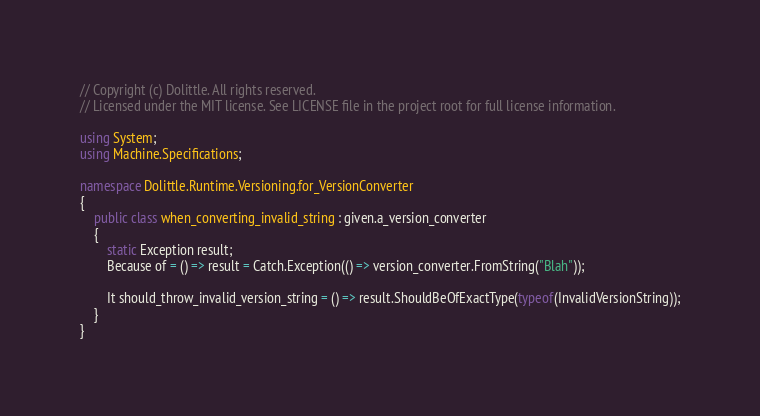<code> <loc_0><loc_0><loc_500><loc_500><_C#_>// Copyright (c) Dolittle. All rights reserved.
// Licensed under the MIT license. See LICENSE file in the project root for full license information.

using System;
using Machine.Specifications;

namespace Dolittle.Runtime.Versioning.for_VersionConverter
{
    public class when_converting_invalid_string : given.a_version_converter
    {
        static Exception result;
        Because of = () => result = Catch.Exception(() => version_converter.FromString("Blah"));

        It should_throw_invalid_version_string = () => result.ShouldBeOfExactType(typeof(InvalidVersionString));
    }
}</code> 